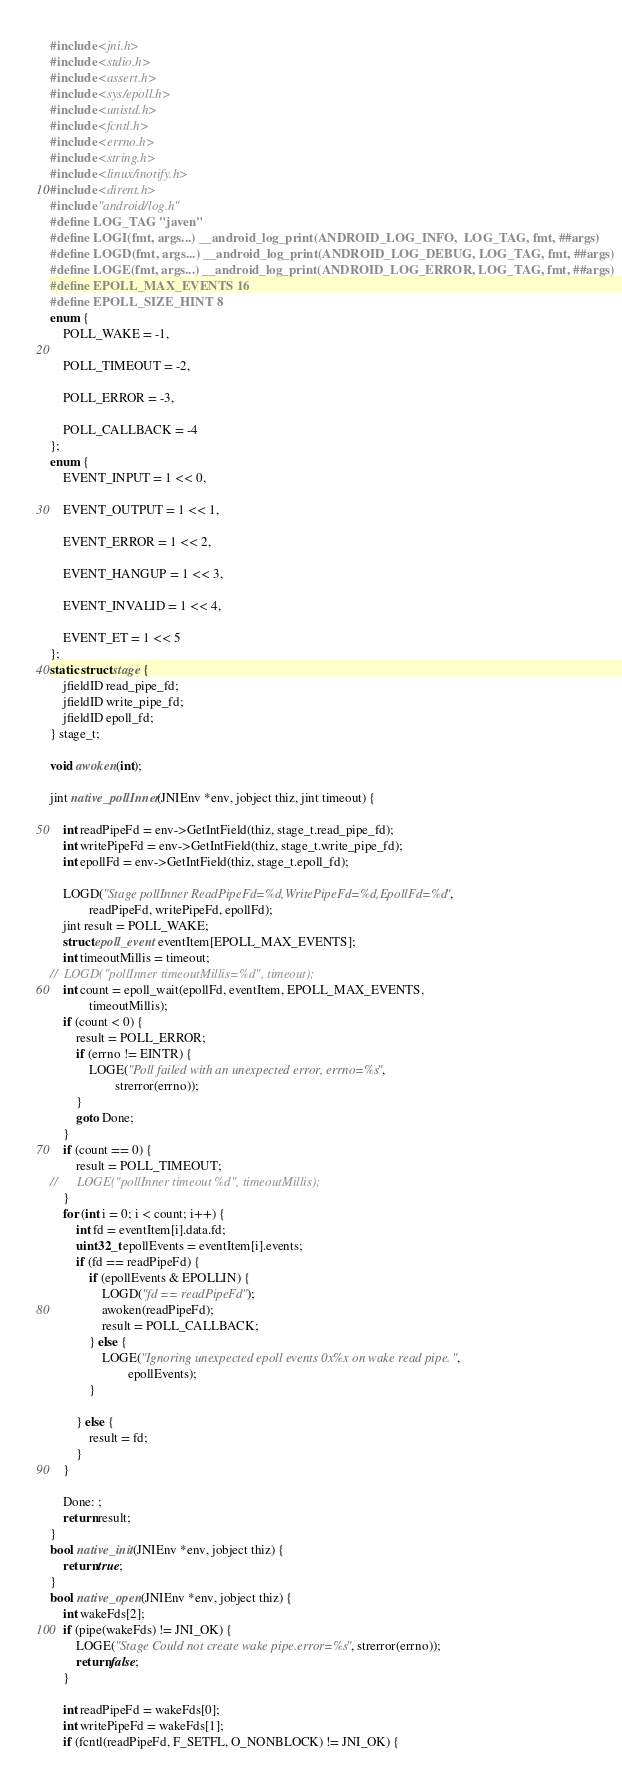Convert code to text. <code><loc_0><loc_0><loc_500><loc_500><_C++_>#include <jni.h>
#include <stdio.h>
#include <assert.h>
#include <sys/epoll.h>
#include <unistd.h>
#include <fcntl.h>
#include <errno.h>
#include <string.h>
#include <linux/inotify.h>
#include <dirent.h>
#include "android/log.h"
#define LOG_TAG "javen"
#define LOGI(fmt, args...) __android_log_print(ANDROID_LOG_INFO,  LOG_TAG, fmt, ##args)
#define LOGD(fmt, args...) __android_log_print(ANDROID_LOG_DEBUG, LOG_TAG, fmt, ##args)
#define LOGE(fmt, args...) __android_log_print(ANDROID_LOG_ERROR, LOG_TAG, fmt, ##args)
#define EPOLL_MAX_EVENTS 16
#define EPOLL_SIZE_HINT 8
enum {
	POLL_WAKE = -1,

	POLL_TIMEOUT = -2,

	POLL_ERROR = -3,

	POLL_CALLBACK = -4
};
enum {
	EVENT_INPUT = 1 << 0,

	EVENT_OUTPUT = 1 << 1,

	EVENT_ERROR = 1 << 2,

	EVENT_HANGUP = 1 << 3,

	EVENT_INVALID = 1 << 4,

	EVENT_ET = 1 << 5
};
static struct stage {
	jfieldID read_pipe_fd;
	jfieldID write_pipe_fd;
	jfieldID epoll_fd;
} stage_t;

void awoken(int);

jint native_pollInner(JNIEnv *env, jobject thiz, jint timeout) {

	int readPipeFd = env->GetIntField(thiz, stage_t.read_pipe_fd);
	int writePipeFd = env->GetIntField(thiz, stage_t.write_pipe_fd);
	int epollFd = env->GetIntField(thiz, stage_t.epoll_fd);

	LOGD("Stage pollInner ReadPipeFd=%d,WritePipeFd=%d,EpollFd=%d",
			readPipeFd, writePipeFd, epollFd);
	jint result = POLL_WAKE;
	struct epoll_event eventItem[EPOLL_MAX_EVENTS];
	int timeoutMillis = timeout;
//	LOGD("pollInner timeoutMillis=%d", timeout);
	int count = epoll_wait(epollFd, eventItem, EPOLL_MAX_EVENTS,
			timeoutMillis);
	if (count < 0) {
		result = POLL_ERROR;
		if (errno != EINTR) {
			LOGE("Poll failed with an unexpected error, errno=%s",
					strerror(errno));
		}
		goto Done;
	}
	if (count == 0) {
		result = POLL_TIMEOUT;
//		LOGE("pollInner timeout %d", timeoutMillis);
	}
	for (int i = 0; i < count; i++) {
		int fd = eventItem[i].data.fd;
		uint32_t epollEvents = eventItem[i].events;
		if (fd == readPipeFd) {
			if (epollEvents & EPOLLIN) {
				LOGD("fd == readPipeFd");
				awoken(readPipeFd);
				result = POLL_CALLBACK;
			} else {
				LOGE("Ignoring unexpected epoll events 0x%x on wake read pipe.",
						epollEvents);
			}

		} else {
			result = fd;
		}
	}

	Done: ;
	return result;
}
bool native_init(JNIEnv *env, jobject thiz) {
	return true;
}
bool native_open(JNIEnv *env, jobject thiz) {
	int wakeFds[2];
	if (pipe(wakeFds) != JNI_OK) {
		LOGE("Stage Could not create wake pipe.error=%s", strerror(errno));
		return false;
	}

	int readPipeFd = wakeFds[0];
	int writePipeFd = wakeFds[1];
	if (fcntl(readPipeFd, F_SETFL, O_NONBLOCK) != JNI_OK) {</code> 